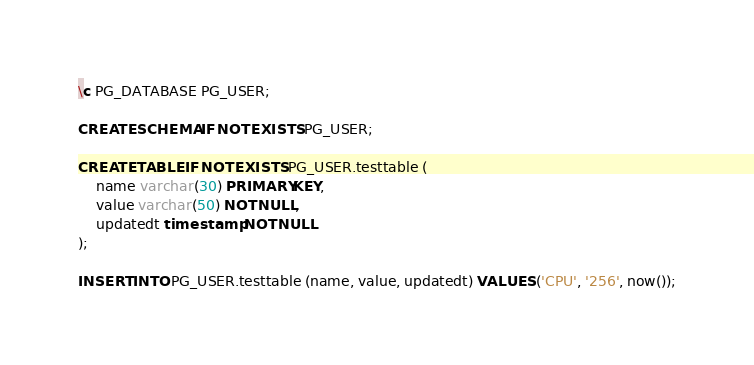Convert code to text. <code><loc_0><loc_0><loc_500><loc_500><_SQL_>\c PG_DATABASE PG_USER;

CREATE SCHEMA IF NOT EXISTS PG_USER;

CREATE TABLE IF NOT EXISTS PG_USER.testtable (
	name varchar(30) PRIMARY KEY,
	value varchar(50) NOT NULL,
	updatedt timestamp NOT NULL
);

INSERT INTO PG_USER.testtable (name, value, updatedt) VALUES ('CPU', '256', now());
</code> 